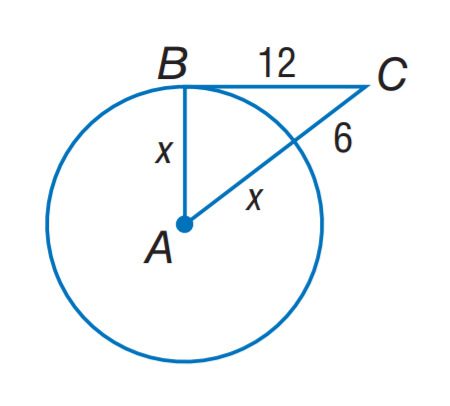Question: The segment is tangent to the circle. Find x.
Choices:
A. 6
B. 8
C. 9
D. 12
Answer with the letter. Answer: C 